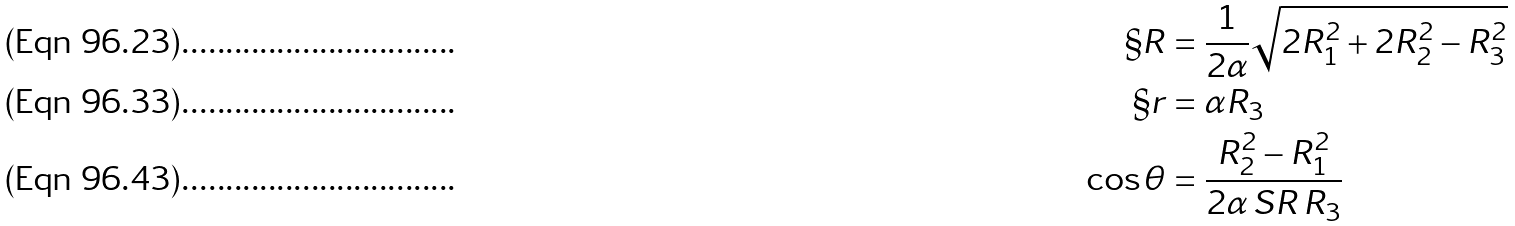<formula> <loc_0><loc_0><loc_500><loc_500>\S R & = \frac { 1 } { 2 \alpha } \sqrt { 2 R _ { 1 } ^ { 2 } + 2 R _ { 2 } ^ { 2 } - R _ { 3 } ^ { 2 } } \\ \S r & = \alpha R _ { 3 } \\ \cos \theta & = \frac { R _ { 2 } ^ { 2 } - R _ { 1 } ^ { 2 } } { 2 \alpha \, S R \, R _ { 3 } }</formula> 